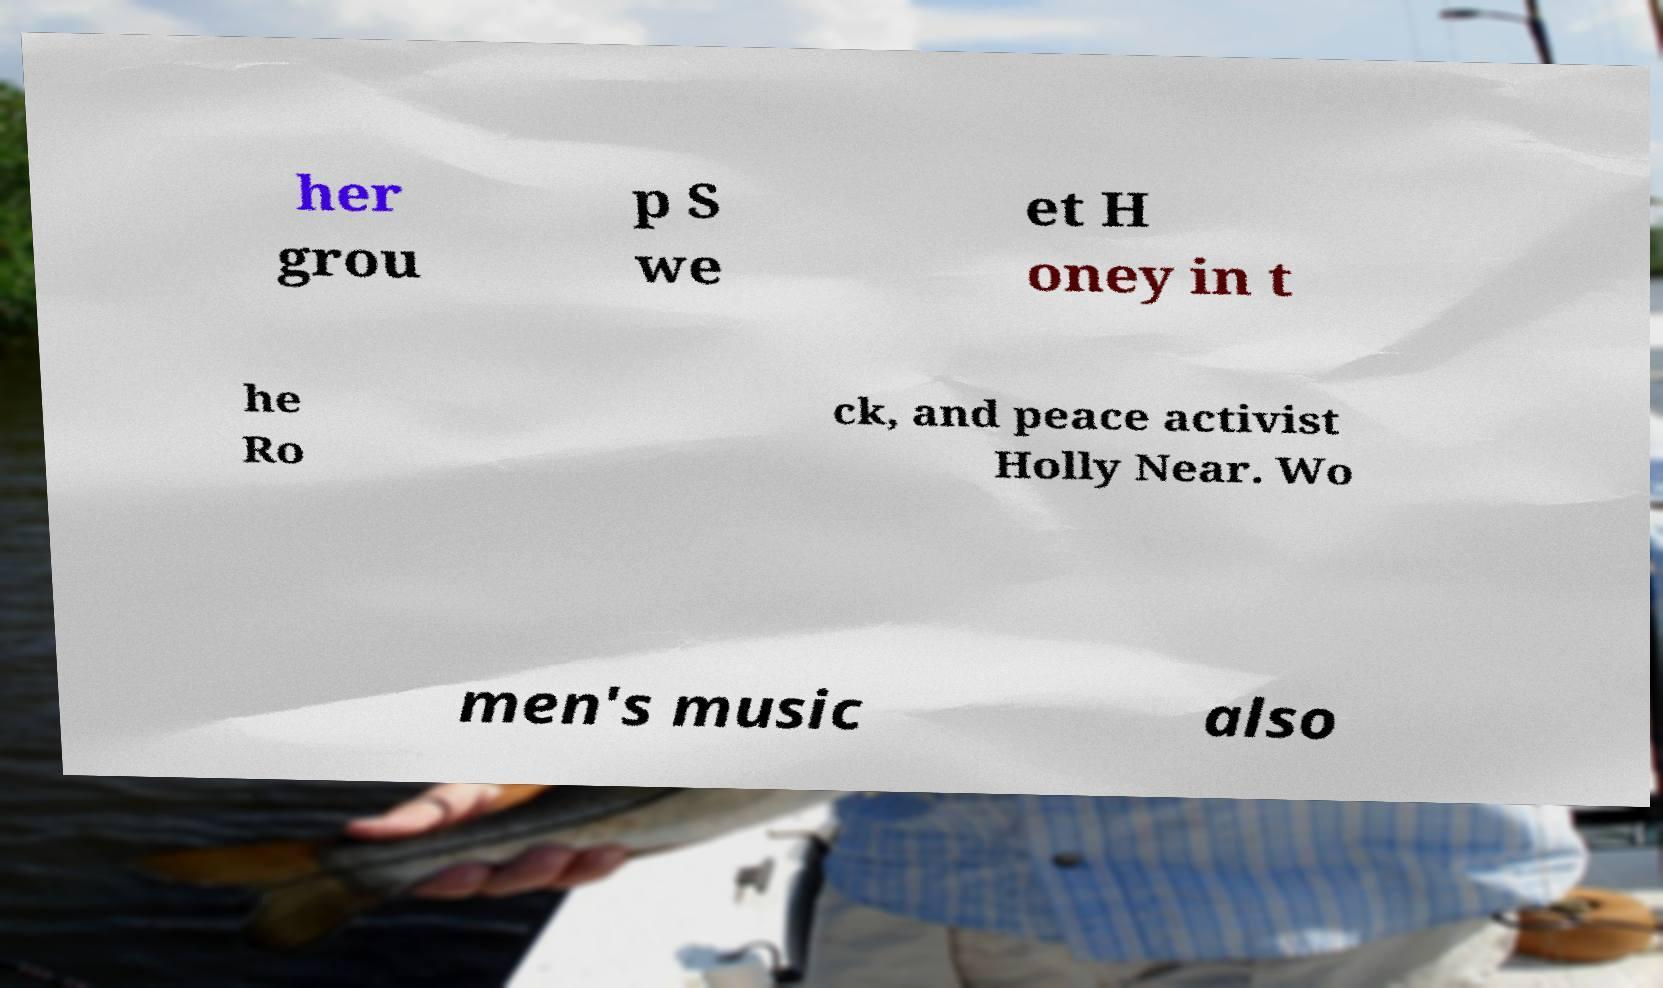For documentation purposes, I need the text within this image transcribed. Could you provide that? her grou p S we et H oney in t he Ro ck, and peace activist Holly Near. Wo men's music also 